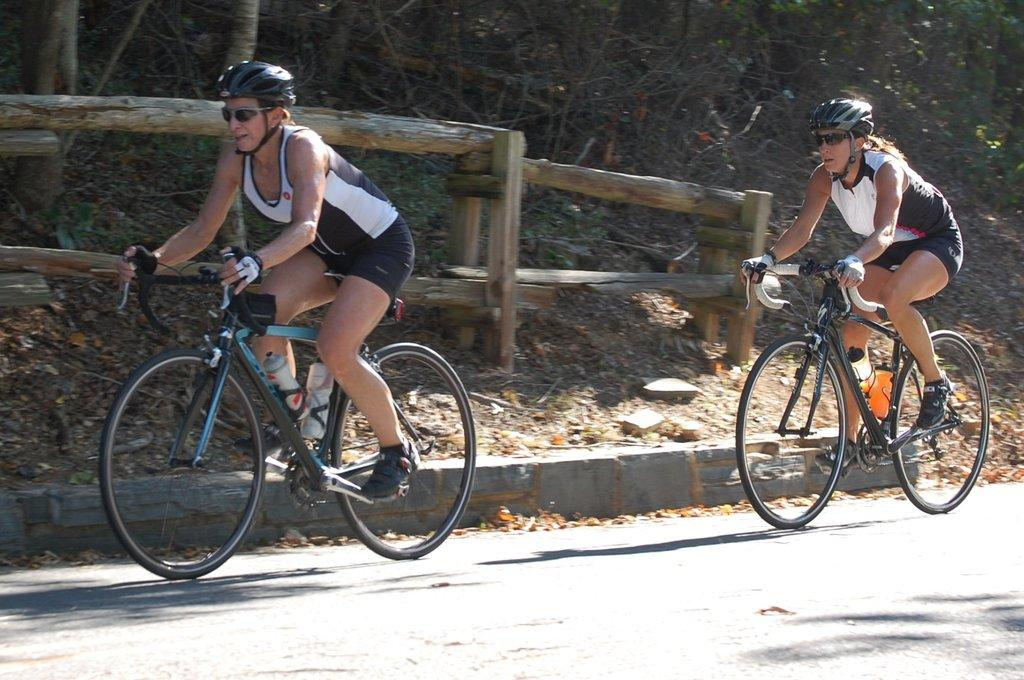How many people are in the image? There are two women in the image. What are the women doing in the image? The women are riding bicycles. Where are the women located in the image? The women are on a road. What can be seen in the background of the image? There are trees visible in the background of the image. What type of art or prose is being created by the women in the image? There is no indication in the image that the women are creating any art or prose; they are simply riding bicycles. 